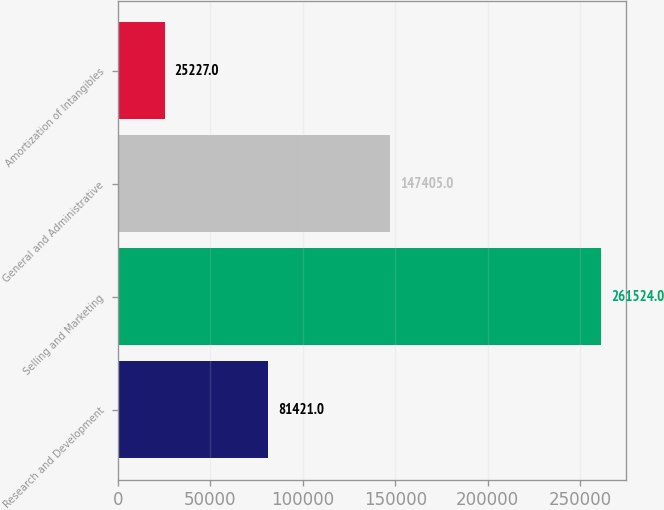Convert chart to OTSL. <chart><loc_0><loc_0><loc_500><loc_500><bar_chart><fcel>Research and Development<fcel>Selling and Marketing<fcel>General and Administrative<fcel>Amortization of Intangibles<nl><fcel>81421<fcel>261524<fcel>147405<fcel>25227<nl></chart> 